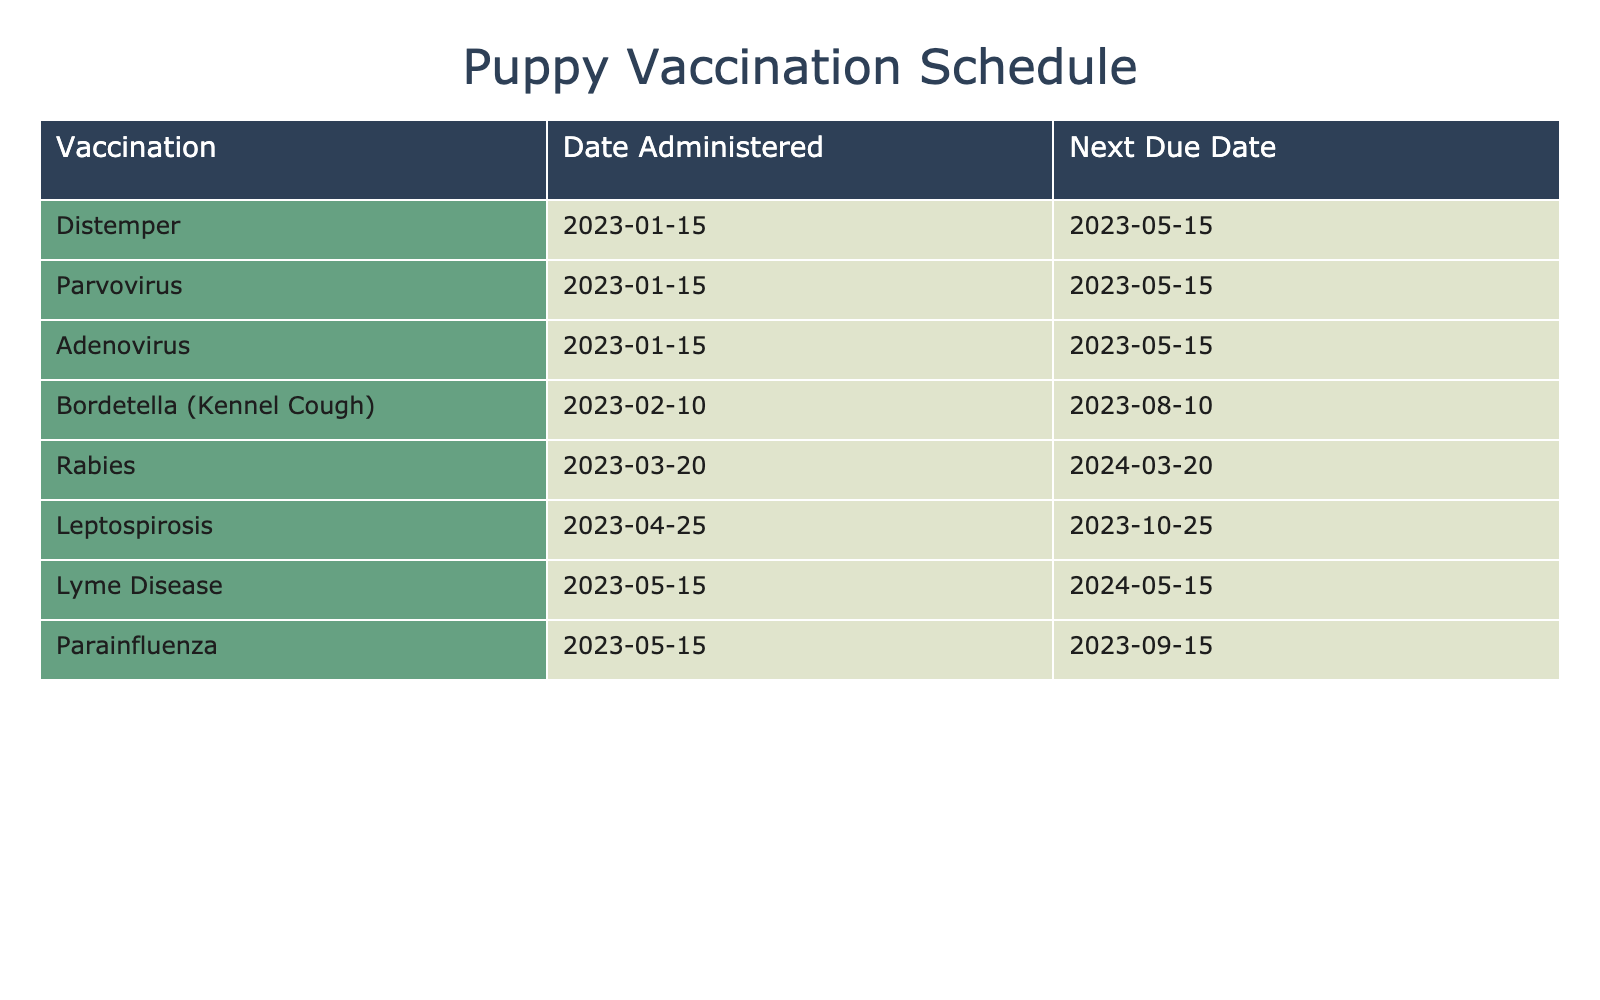What is the due date for the Distemper vaccination? The due date for Distemper vaccination is listed directly in the table under the "Next Due Date" column for that vaccination, which is May 15, 2023.
Answer: May 15, 2023 How many vaccinations are due before August 2023? By looking at the "Next Due Date" column, I find that the vaccinations due before August 2023 are Distemper, Parvovirus, Adenovirus (due May 15, 2023), and Bordetella (due August 10, 2023). This makes a total of 4 vaccinations.
Answer: 4 Which vaccination is due last in the first year? To find the last vaccination due in the first year, I check the "Next Due Date" column for all vaccinations. The latest date is for the Rabies vaccination, which is due on March 20, 2024.
Answer: March 20, 2024 Is the Leptospirosis vaccination due before the second Bordetella vaccination? Leptospirosis is due on October 25, 2023, and Bordetella is due on August 10, 2023. Since August 10, 2023, comes before October 25, 2023, the statement is true; Leptospirosis is due later.
Answer: No How many months are between the Parainfluenza vaccination and its next due date? The Parainfluenza vaccination was given on May 15, 2023, and its next due date is September 15, 2023. The time between these two dates is 4 months, as May to September counts as four months.
Answer: 4 months Which vaccinations are due in the same month? By reviewing the "Next Due Date" column, I see that both Distemper, Parvovirus, and Adenovirus are due in May, specifically on May 15, 2023. Hence, these three vaccinations are due in the same month.
Answer: Distemper, Parvovirus, Adenovirus Are there any vaccinations due in September 2023? The table lists Parainfluenza, which is due on September 15, 2023. So, there is a vaccination due in this month.
Answer: Yes What is the time interval between the first vaccination date and the last due date? The first vaccination date is January 15, 2023, for Distemper, and the last due date for Rabies is March 20, 2024. The time between these two dates (1 year and 2 months) can be calculated. Counting from January 15, 2023, to March 20, 2024, is 1 year and a little over 2 months.
Answer: 1 year and 2 months 